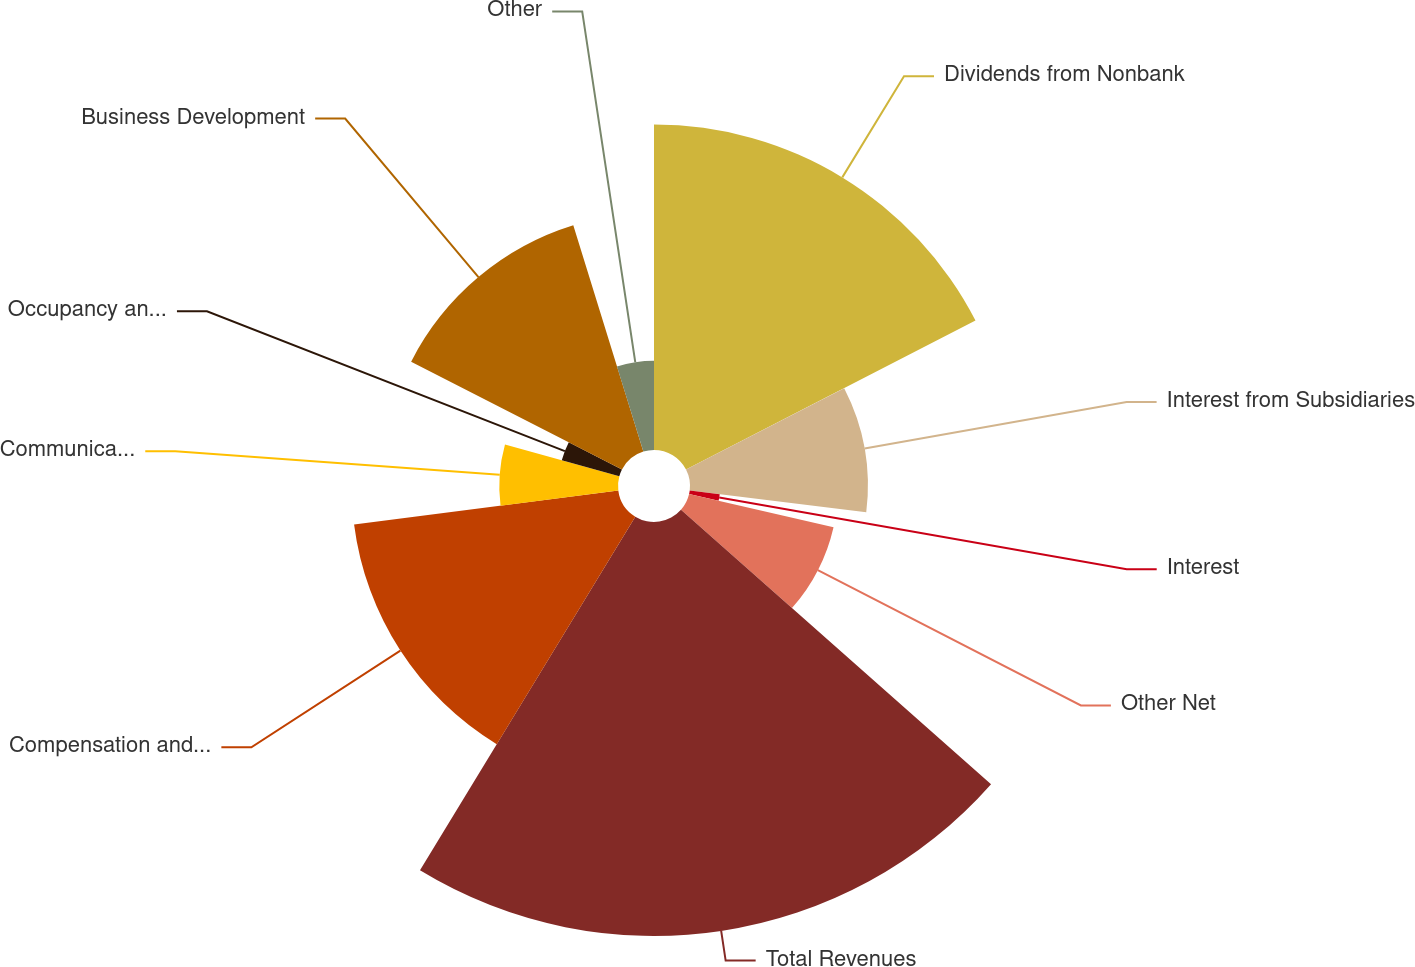Convert chart. <chart><loc_0><loc_0><loc_500><loc_500><pie_chart><fcel>Dividends from Nonbank<fcel>Interest from Subsidiaries<fcel>Interest<fcel>Other Net<fcel>Total Revenues<fcel>Compensation and Benefits<fcel>Communications and Information<fcel>Occupancy and Equipment Costs<fcel>Business Development<fcel>Other<nl><fcel>17.44%<fcel>9.53%<fcel>1.62%<fcel>7.94%<fcel>22.18%<fcel>14.27%<fcel>6.36%<fcel>3.2%<fcel>12.69%<fcel>4.78%<nl></chart> 